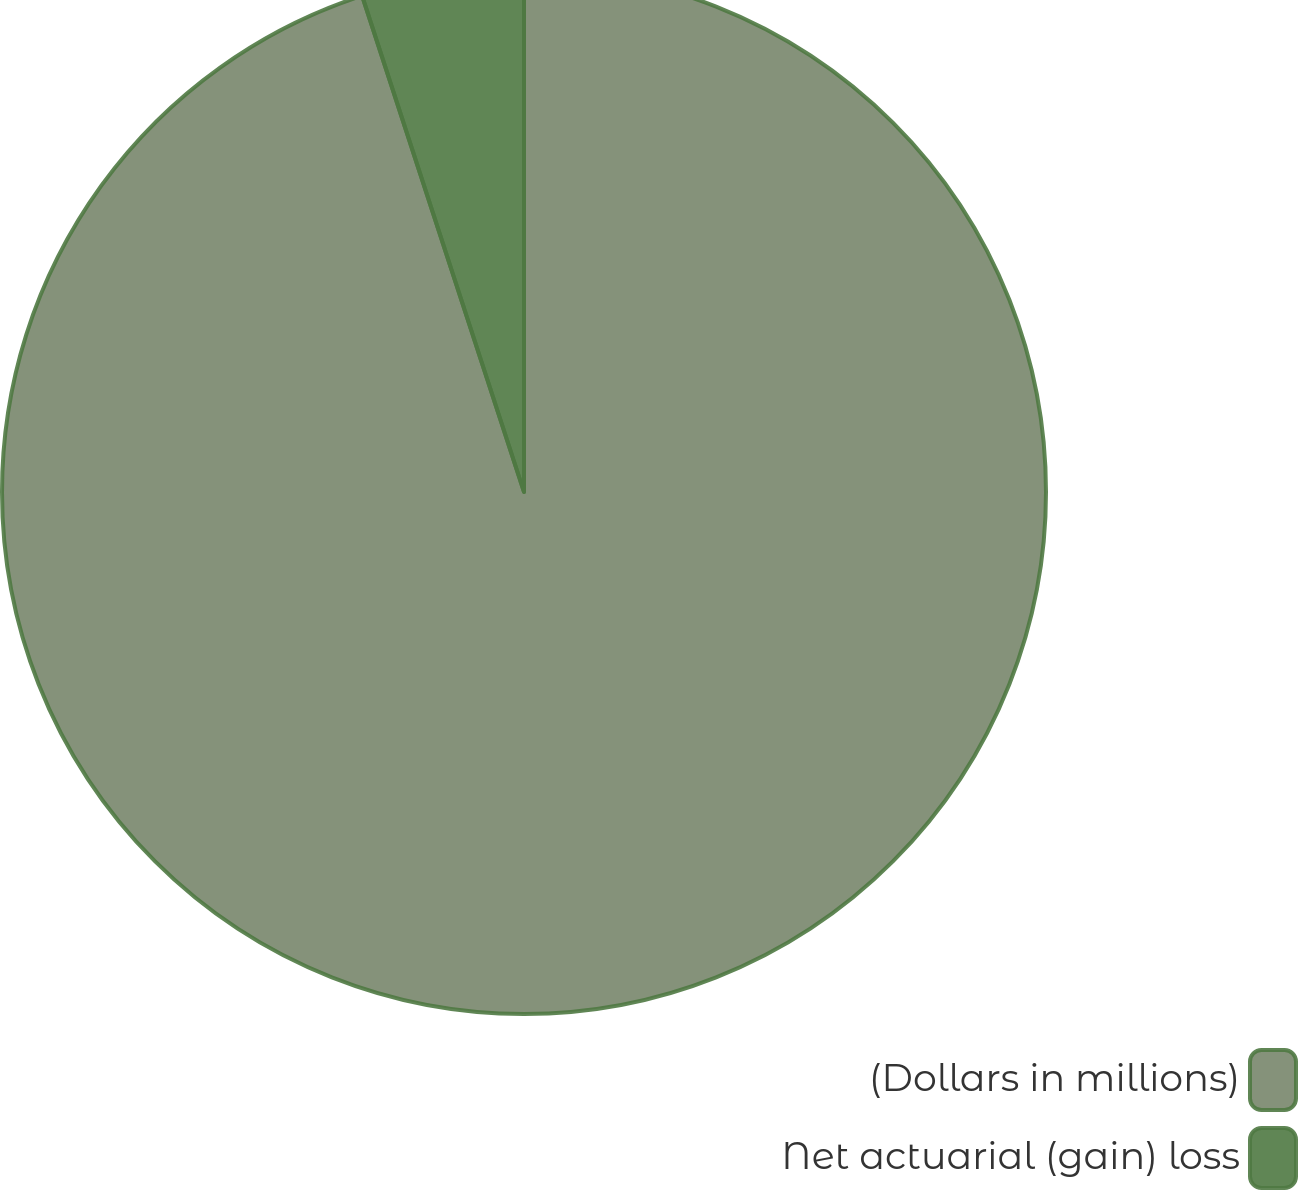<chart> <loc_0><loc_0><loc_500><loc_500><pie_chart><fcel>(Dollars in millions)<fcel>Net actuarial (gain) loss<nl><fcel>94.98%<fcel>5.02%<nl></chart> 